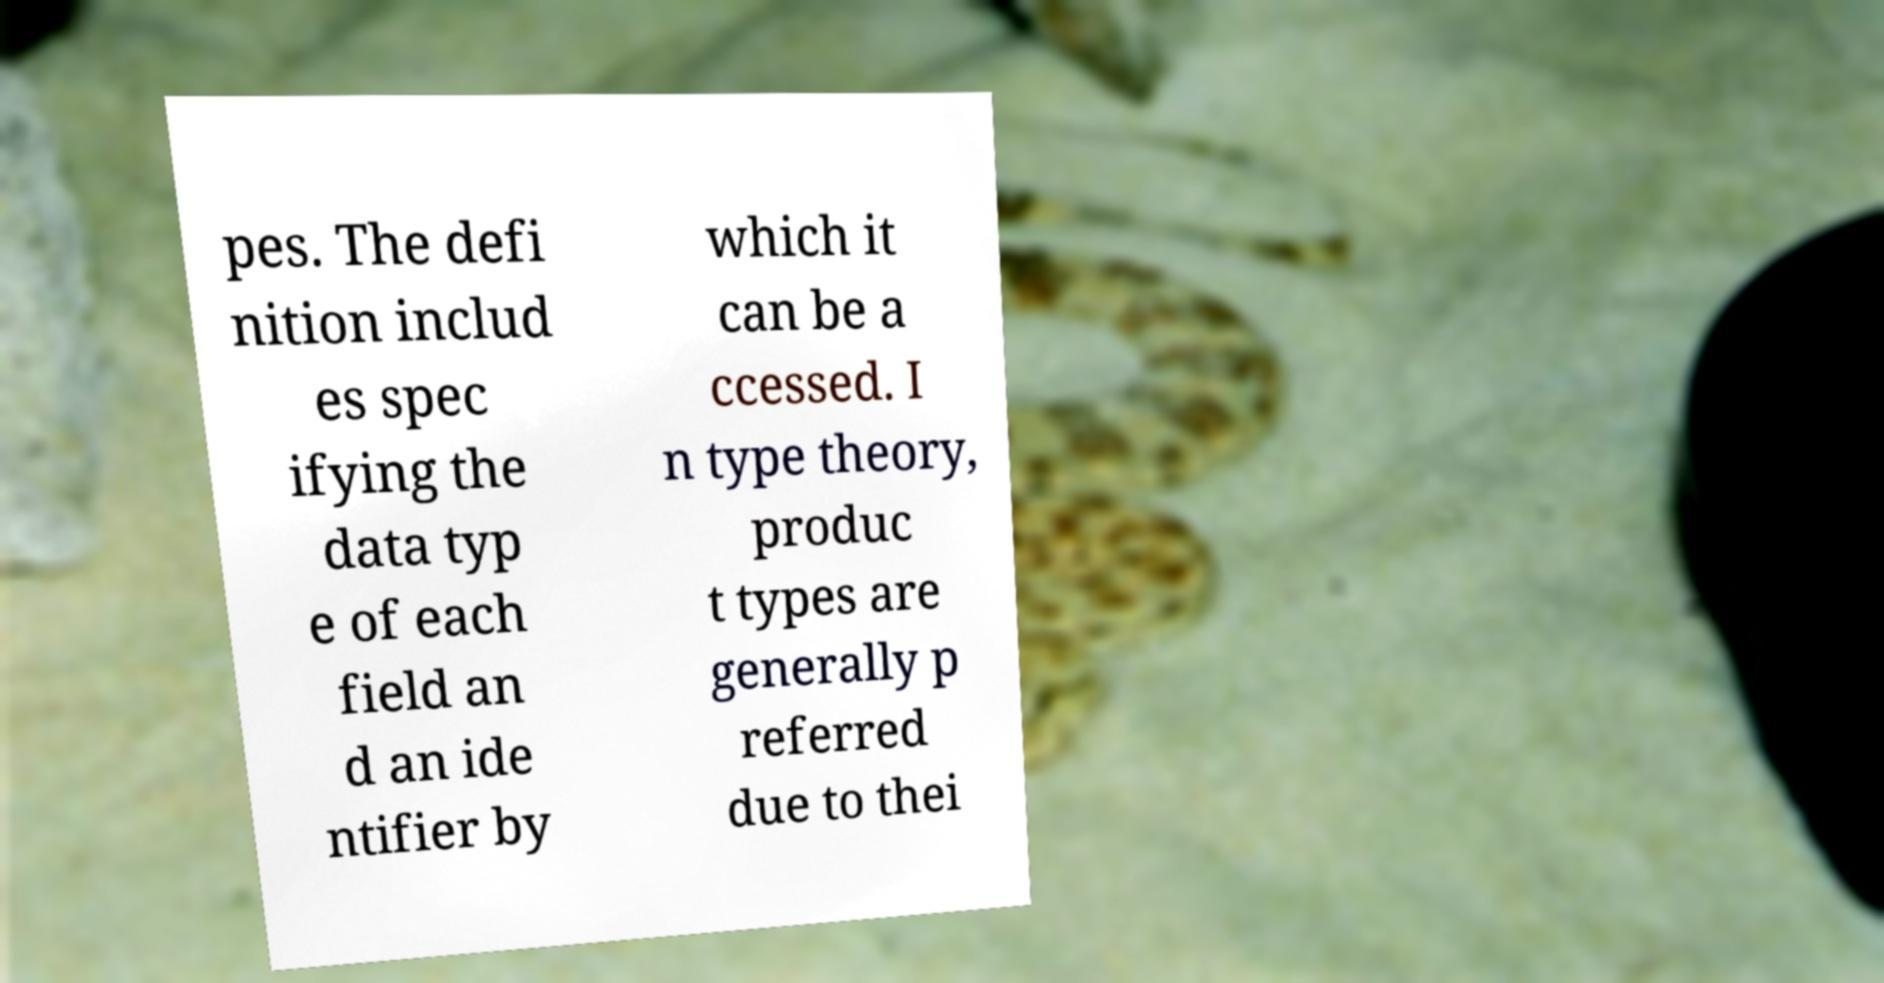There's text embedded in this image that I need extracted. Can you transcribe it verbatim? pes. The defi nition includ es spec ifying the data typ e of each field an d an ide ntifier by which it can be a ccessed. I n type theory, produc t types are generally p referred due to thei 